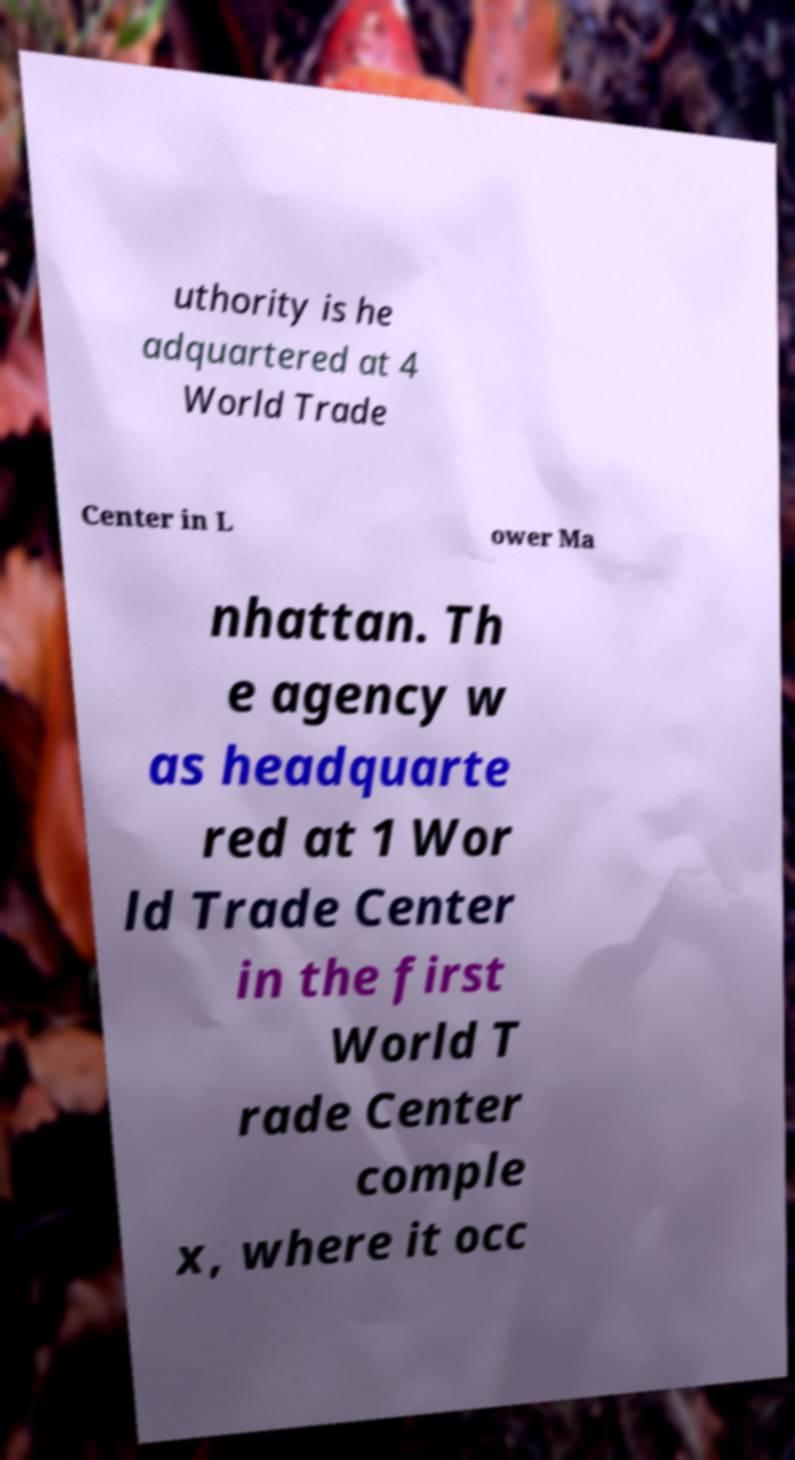For documentation purposes, I need the text within this image transcribed. Could you provide that? uthority is he adquartered at 4 World Trade Center in L ower Ma nhattan. Th e agency w as headquarte red at 1 Wor ld Trade Center in the first World T rade Center comple x, where it occ 